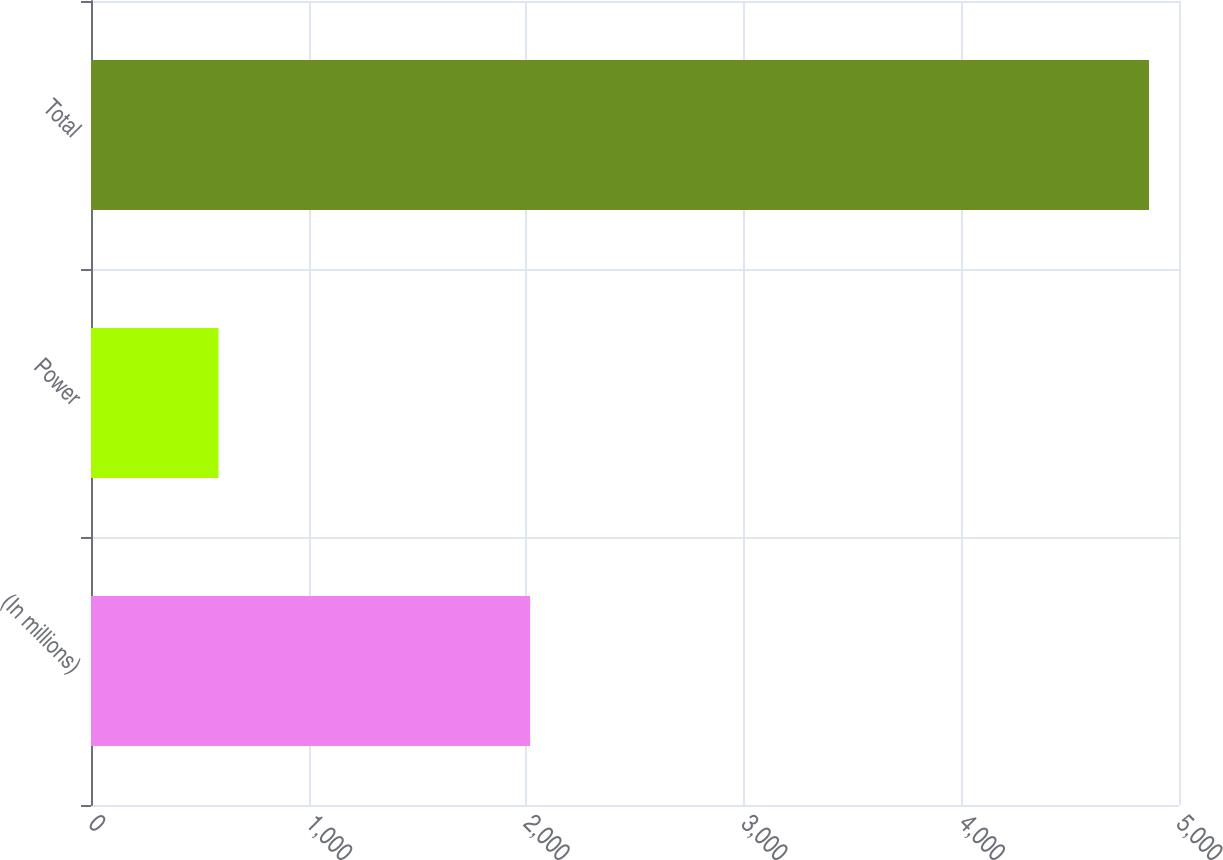Convert chart to OTSL. <chart><loc_0><loc_0><loc_500><loc_500><bar_chart><fcel>(In millions)<fcel>Power<fcel>Total<nl><fcel>2018<fcel>586<fcel>4862<nl></chart> 